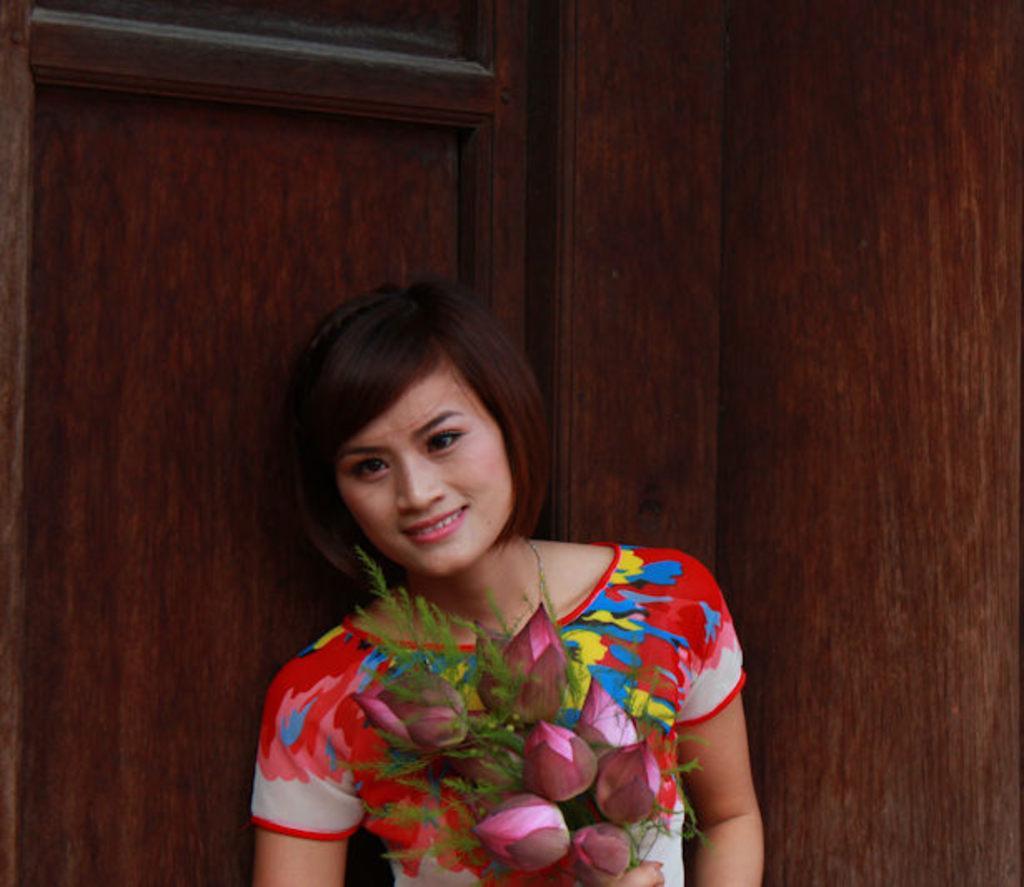Can you describe this image briefly? In this image we can see a person standing with a bouquet, wearing a colorful dress and behind the person there is a brown color object. 